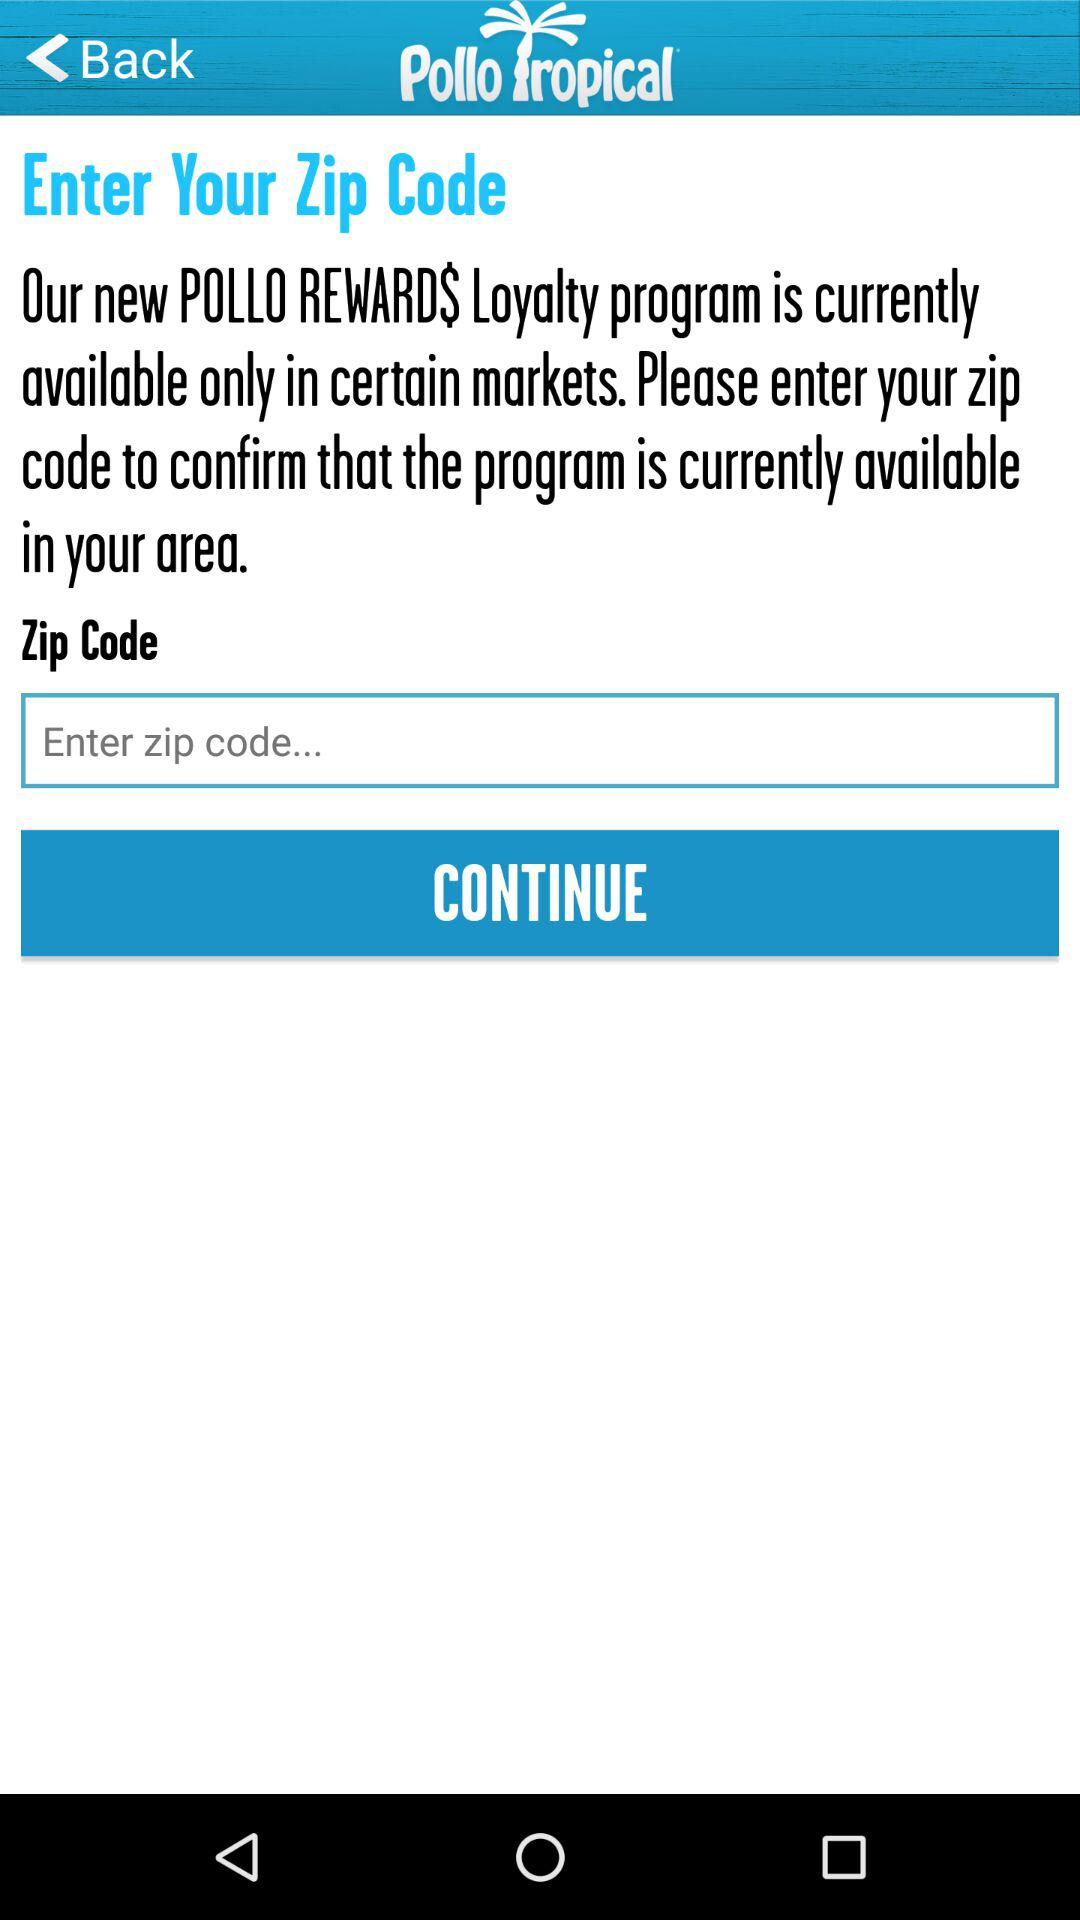What program is currently available? The currently available program is "POLLO REWARDS Loyalty". 